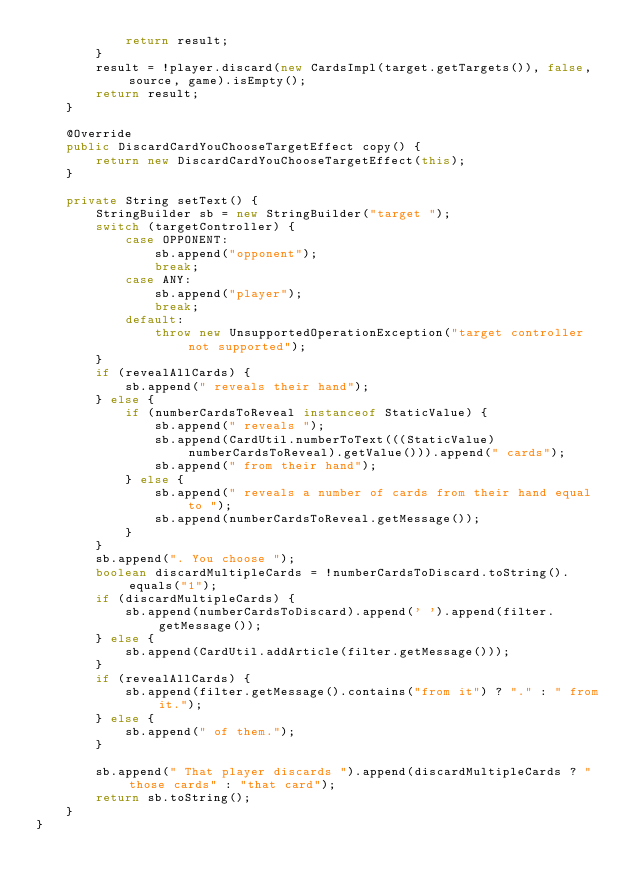Convert code to text. <code><loc_0><loc_0><loc_500><loc_500><_Java_>            return result;
        }
        result = !player.discard(new CardsImpl(target.getTargets()), false, source, game).isEmpty();
        return result;
    }

    @Override
    public DiscardCardYouChooseTargetEffect copy() {
        return new DiscardCardYouChooseTargetEffect(this);
    }

    private String setText() {
        StringBuilder sb = new StringBuilder("target ");
        switch (targetController) {
            case OPPONENT:
                sb.append("opponent");
                break;
            case ANY:
                sb.append("player");
                break;
            default:
                throw new UnsupportedOperationException("target controller not supported");
        }
        if (revealAllCards) {
            sb.append(" reveals their hand");
        } else {
            if (numberCardsToReveal instanceof StaticValue) {
                sb.append(" reveals ");
                sb.append(CardUtil.numberToText(((StaticValue) numberCardsToReveal).getValue())).append(" cards");
                sb.append(" from their hand");
            } else {
                sb.append(" reveals a number of cards from their hand equal to ");
                sb.append(numberCardsToReveal.getMessage());
            }
        }
        sb.append(". You choose ");
        boolean discardMultipleCards = !numberCardsToDiscard.toString().equals("1");
        if (discardMultipleCards) {
            sb.append(numberCardsToDiscard).append(' ').append(filter.getMessage());
        } else {
            sb.append(CardUtil.addArticle(filter.getMessage()));
        }
        if (revealAllCards) {
            sb.append(filter.getMessage().contains("from it") ? "." : " from it.");
        } else {
            sb.append(" of them.");
        }

        sb.append(" That player discards ").append(discardMultipleCards ? "those cards" : "that card");
        return sb.toString();
    }
}
</code> 